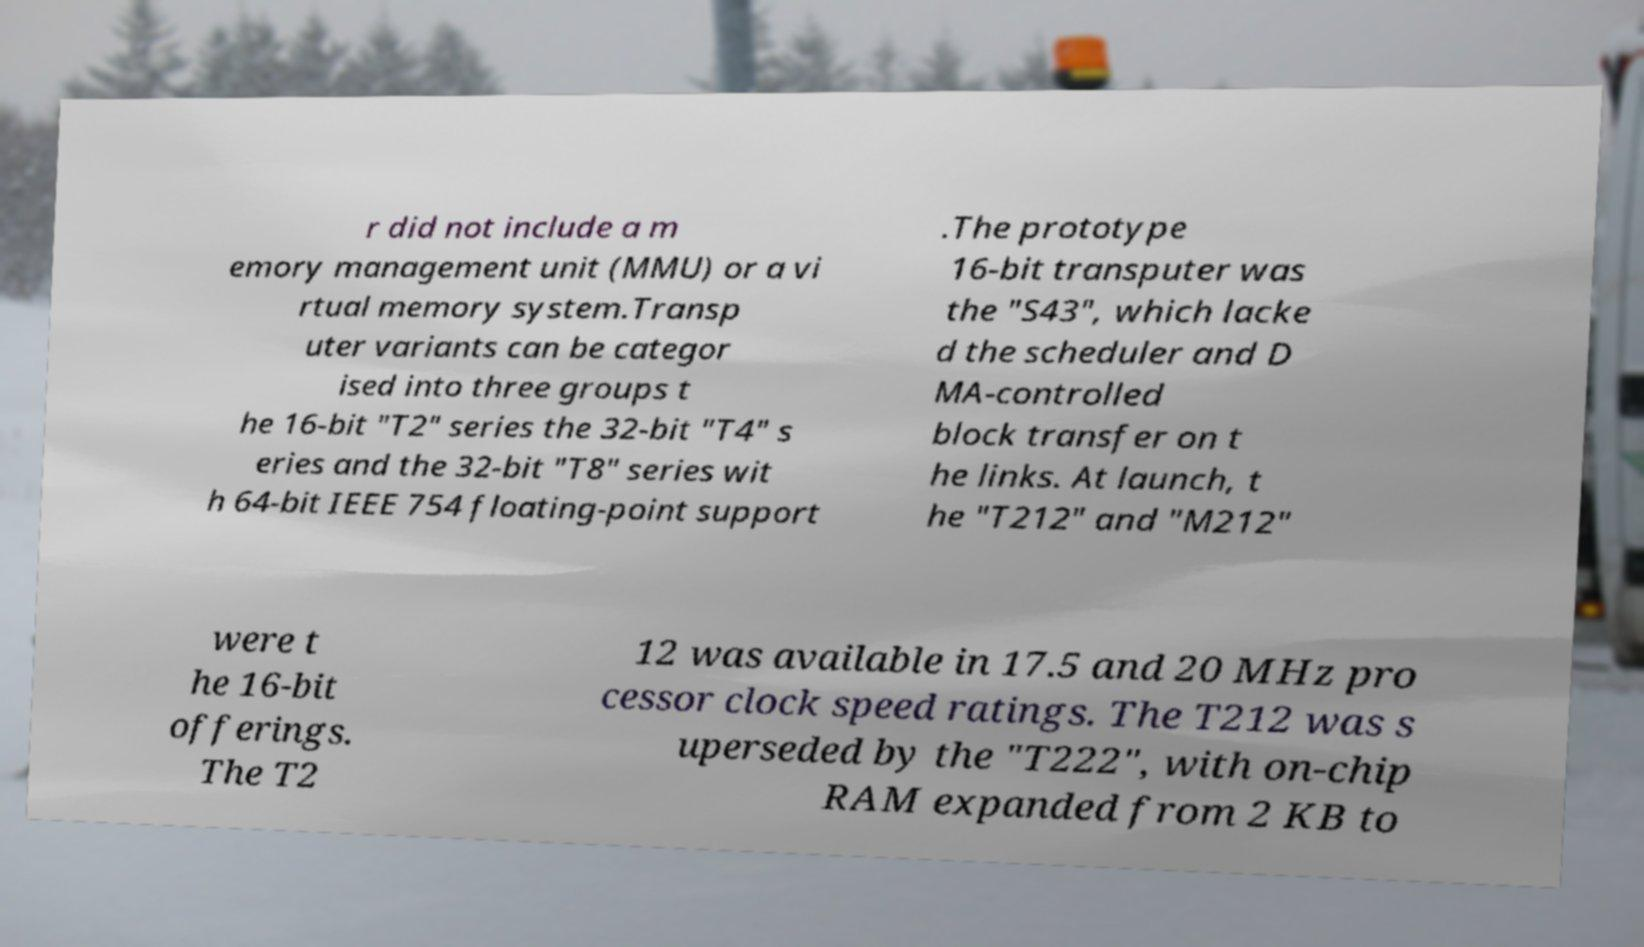Could you extract and type out the text from this image? r did not include a m emory management unit (MMU) or a vi rtual memory system.Transp uter variants can be categor ised into three groups t he 16-bit "T2" series the 32-bit "T4" s eries and the 32-bit "T8" series wit h 64-bit IEEE 754 floating-point support .The prototype 16-bit transputer was the "S43", which lacke d the scheduler and D MA-controlled block transfer on t he links. At launch, t he "T212" and "M212" were t he 16-bit offerings. The T2 12 was available in 17.5 and 20 MHz pro cessor clock speed ratings. The T212 was s uperseded by the "T222", with on-chip RAM expanded from 2 KB to 